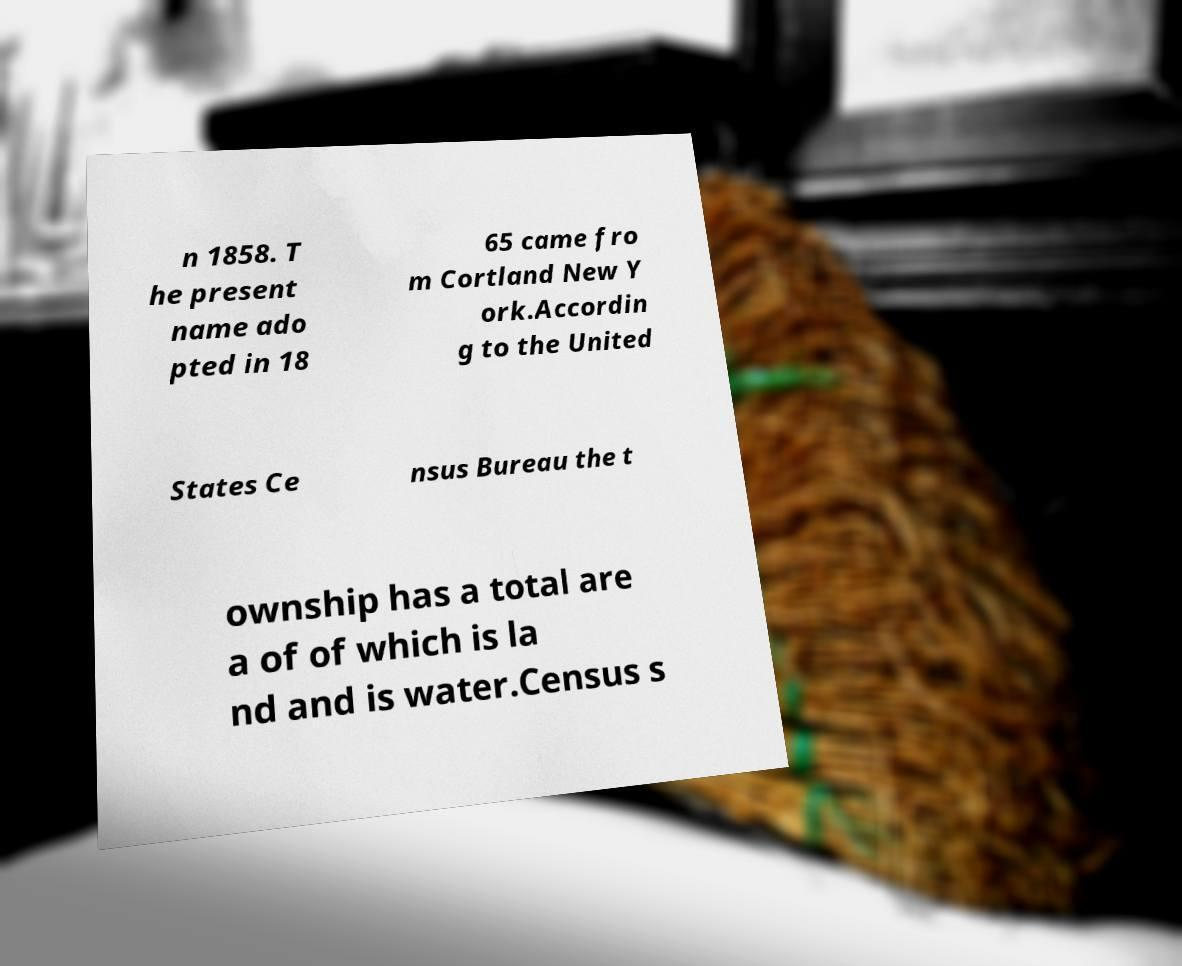I need the written content from this picture converted into text. Can you do that? n 1858. T he present name ado pted in 18 65 came fro m Cortland New Y ork.Accordin g to the United States Ce nsus Bureau the t ownship has a total are a of of which is la nd and is water.Census s 